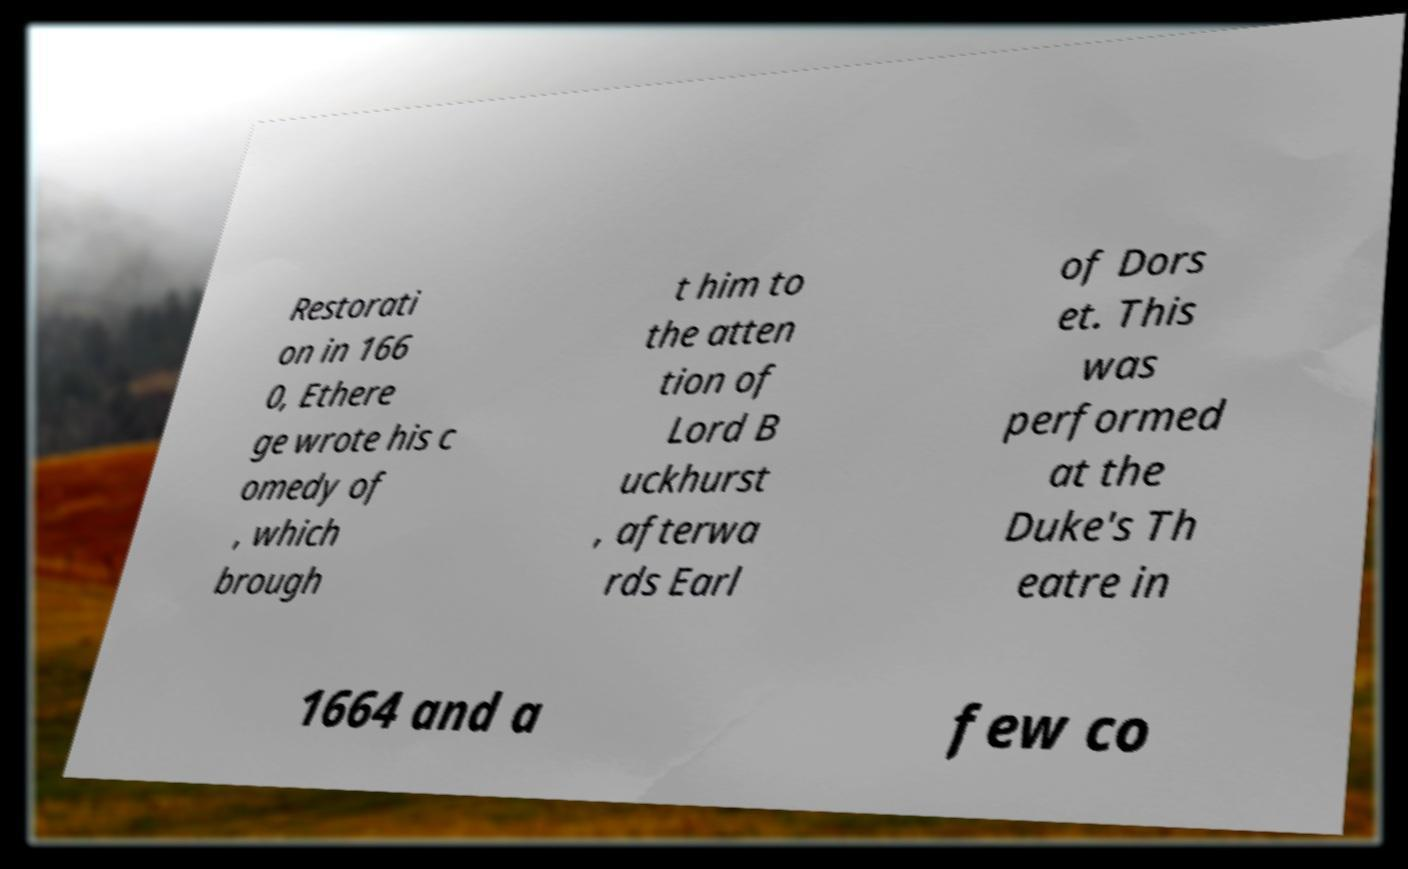Could you extract and type out the text from this image? Restorati on in 166 0, Ethere ge wrote his c omedy of , which brough t him to the atten tion of Lord B uckhurst , afterwa rds Earl of Dors et. This was performed at the Duke's Th eatre in 1664 and a few co 